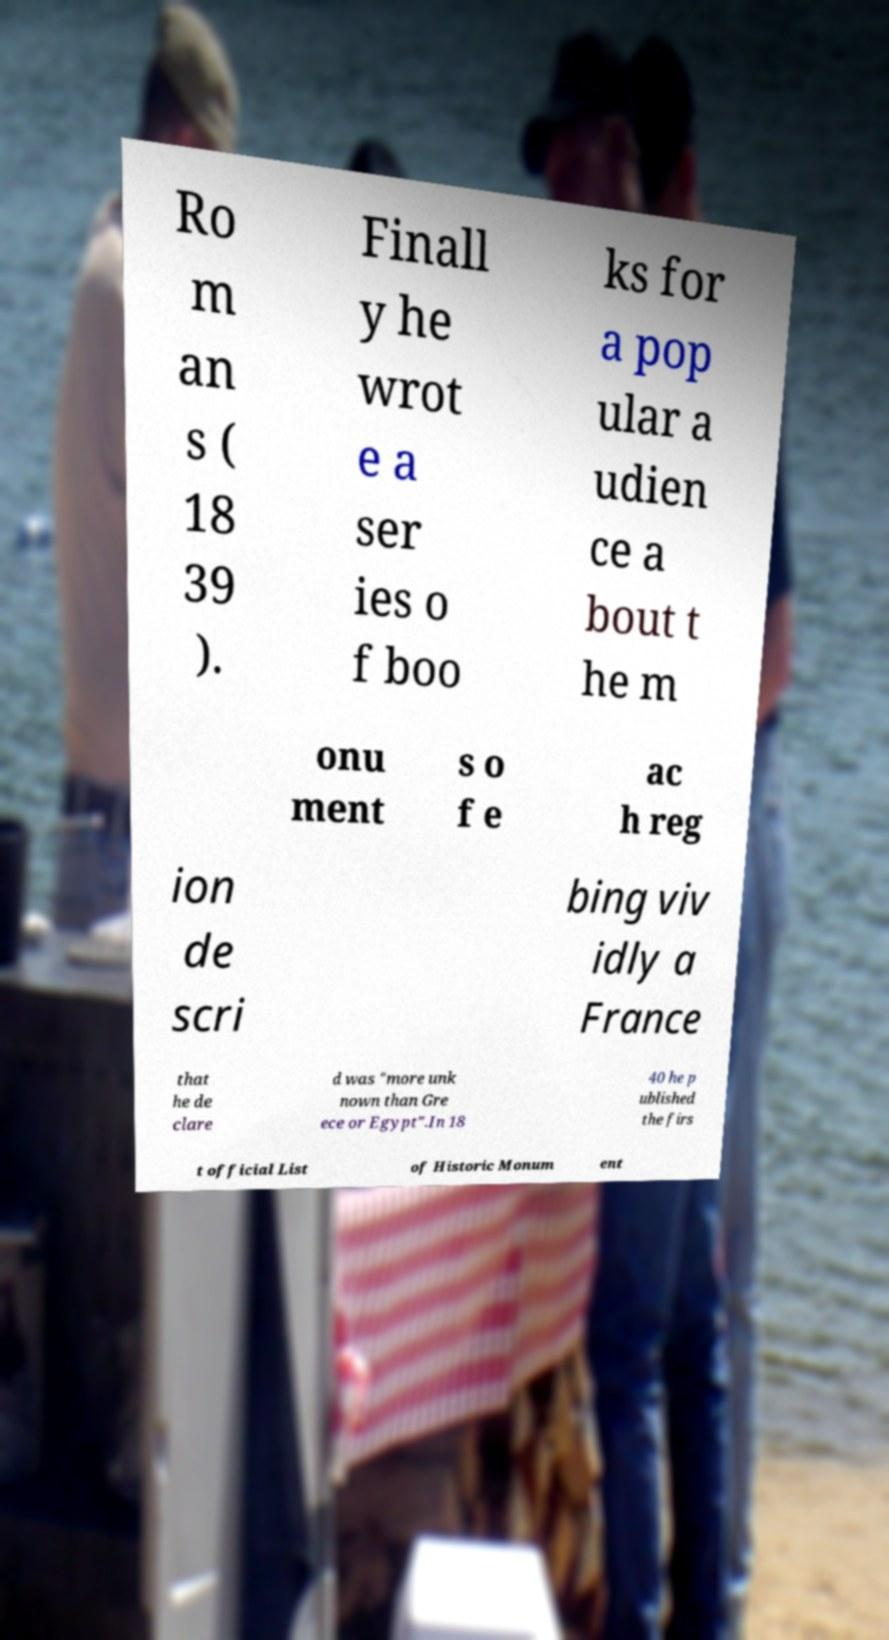Please identify and transcribe the text found in this image. Ro m an s ( 18 39 ). Finall y he wrot e a ser ies o f boo ks for a pop ular a udien ce a bout t he m onu ment s o f e ac h reg ion de scri bing viv idly a France that he de clare d was "more unk nown than Gre ece or Egypt".In 18 40 he p ublished the firs t official List of Historic Monum ent 